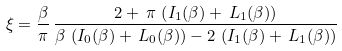<formula> <loc_0><loc_0><loc_500><loc_500>\xi = \frac { \beta } { \pi } \, \frac { 2 + \, \pi \, \left ( I _ { 1 } ( \beta ) + \, { L } _ { 1 } ( \beta ) \right ) } { \beta \, \left ( I _ { 0 } ( \beta ) + \, { L } _ { 0 } ( \beta ) \right ) - 2 \, \left ( I _ { 1 } ( \beta ) + \, { L } _ { 1 } ( \beta ) \right ) }</formula> 